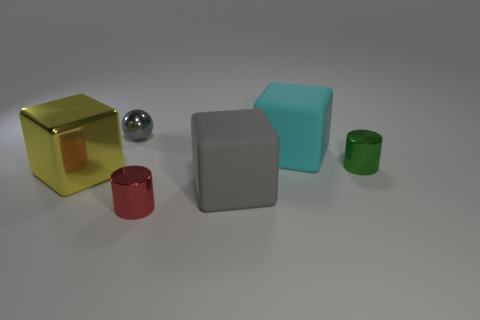Add 2 small purple rubber cylinders. How many objects exist? 8 Subtract all matte blocks. How many blocks are left? 1 Subtract all cyan cubes. How many cubes are left? 2 Subtract 2 cylinders. How many cylinders are left? 0 Subtract all gray cubes. Subtract all gray cylinders. How many cubes are left? 2 Subtract all red blocks. How many brown cylinders are left? 0 Subtract all tiny red metal cylinders. Subtract all green metal things. How many objects are left? 4 Add 6 gray shiny things. How many gray shiny things are left? 7 Add 3 gray shiny spheres. How many gray shiny spheres exist? 4 Subtract 0 blue balls. How many objects are left? 6 